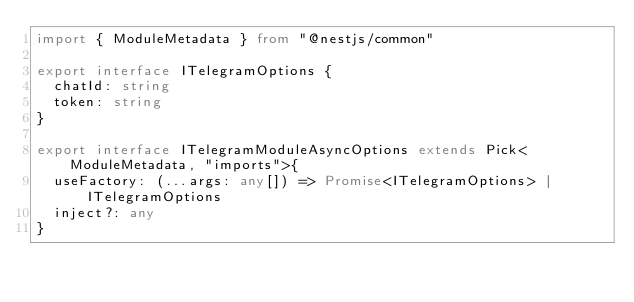<code> <loc_0><loc_0><loc_500><loc_500><_TypeScript_>import { ModuleMetadata } from "@nestjs/common"

export interface ITelegramOptions {
  chatId: string
  token: string
}

export interface ITelegramModuleAsyncOptions extends Pick<ModuleMetadata, "imports">{
  useFactory: (...args: any[]) => Promise<ITelegramOptions> | ITelegramOptions
  inject?: any
}</code> 